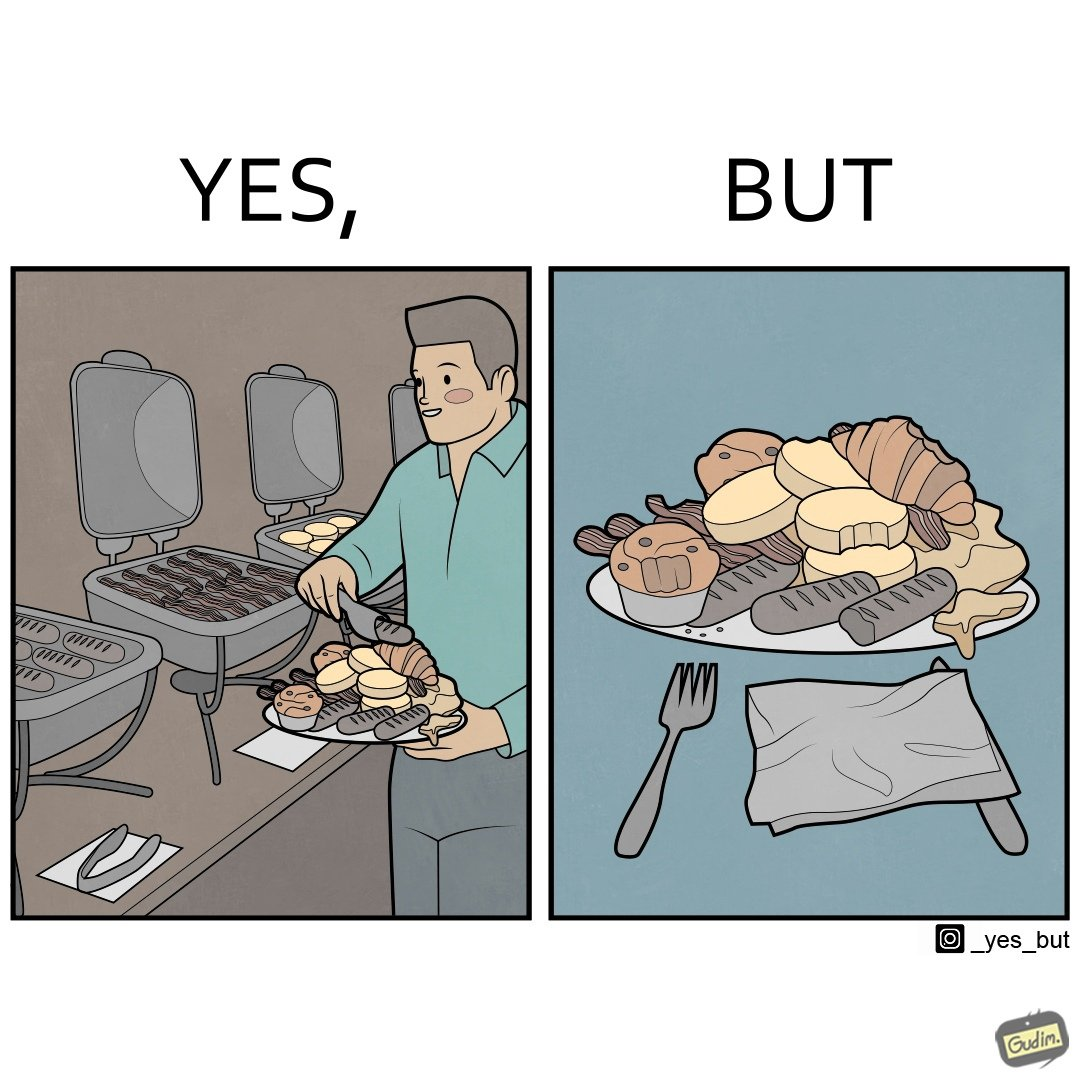What makes this image funny or satirical? The image is satirical because while the man overfils his plate with differnt food items, he ends up wasting almost all of it by not eating them or by taking just one bite out of them leaving the rest. 